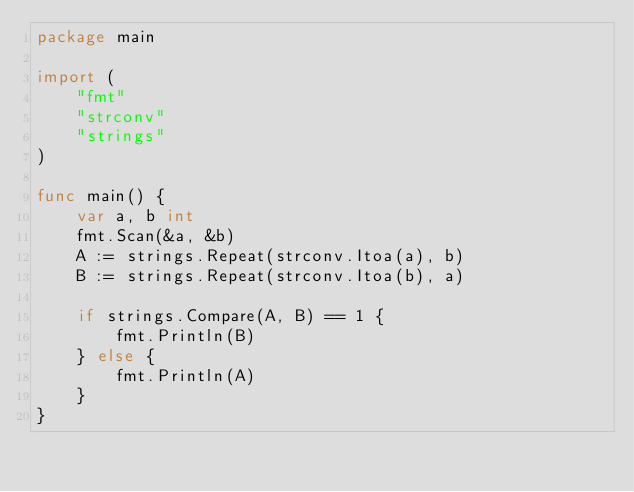Convert code to text. <code><loc_0><loc_0><loc_500><loc_500><_Go_>package main

import (
	"fmt"
	"strconv"
	"strings"
)

func main() {
	var a, b int
	fmt.Scan(&a, &b)
	A := strings.Repeat(strconv.Itoa(a), b)
	B := strings.Repeat(strconv.Itoa(b), a)

	if strings.Compare(A, B) == 1 {
		fmt.Println(B)
	} else {
		fmt.Println(A)
	}
}
</code> 